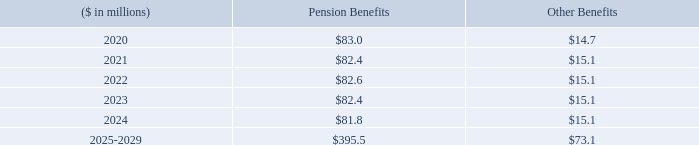Estimated Future Benefit Payments
The following benefit payments, which reflect expected future service, as appropriate, are expected to be paid. Pension benefits are currently paid from plan assets and other benefits are currently paid from corporate assets.
How are pension benefits currently paid? Currently paid from plan assets and other benefits are currently paid from corporate assets. What is the amount of Estimated pension benefit payments expected in 2020? $83.0. What is the  Pension Benefits and Other Benefits for 2021 respectively?
Answer scale should be: million. $82.4, $15.1. In which year from 2020-2024 would the amount for Other Benefits be the lowest? 14.7<15.1
Answer: 2020. What was the change in the amount under other benefits in 2021 from 2020?
Answer scale should be: million. 15.1-14.7
Answer: 0.4. What was the percentage change in the amount under other benefits in 2021 from 2020?
Answer scale should be: percent. (15.1-14.7)/14.7
Answer: 2.72. 